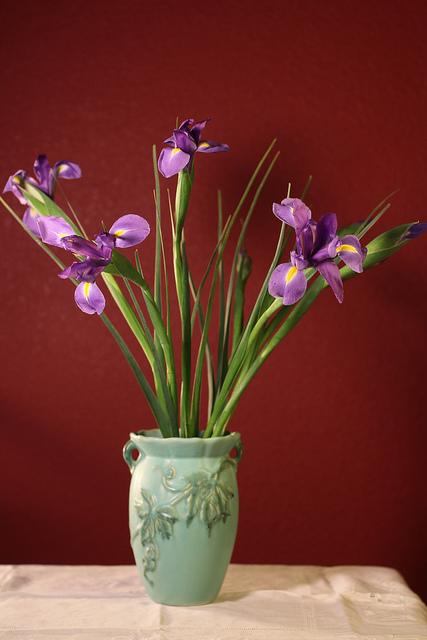What is the main color of the flowers?
Give a very brief answer. Purple. Is the vase modern?
Short answer required. Yes. What color is the background?
Keep it brief. Red. How many purple flowers are in there?
Concise answer only. 4. 